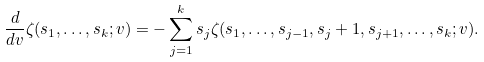Convert formula to latex. <formula><loc_0><loc_0><loc_500><loc_500>\frac { d } { d v } \zeta ( s _ { 1 } , \dots , s _ { k } ; v ) = - \sum _ { j = 1 } ^ { k } s _ { j } \zeta ( s _ { 1 } , \dots , s _ { j - 1 } , s _ { j } + 1 , s _ { j + 1 } , \dots , s _ { k } ; v ) .</formula> 